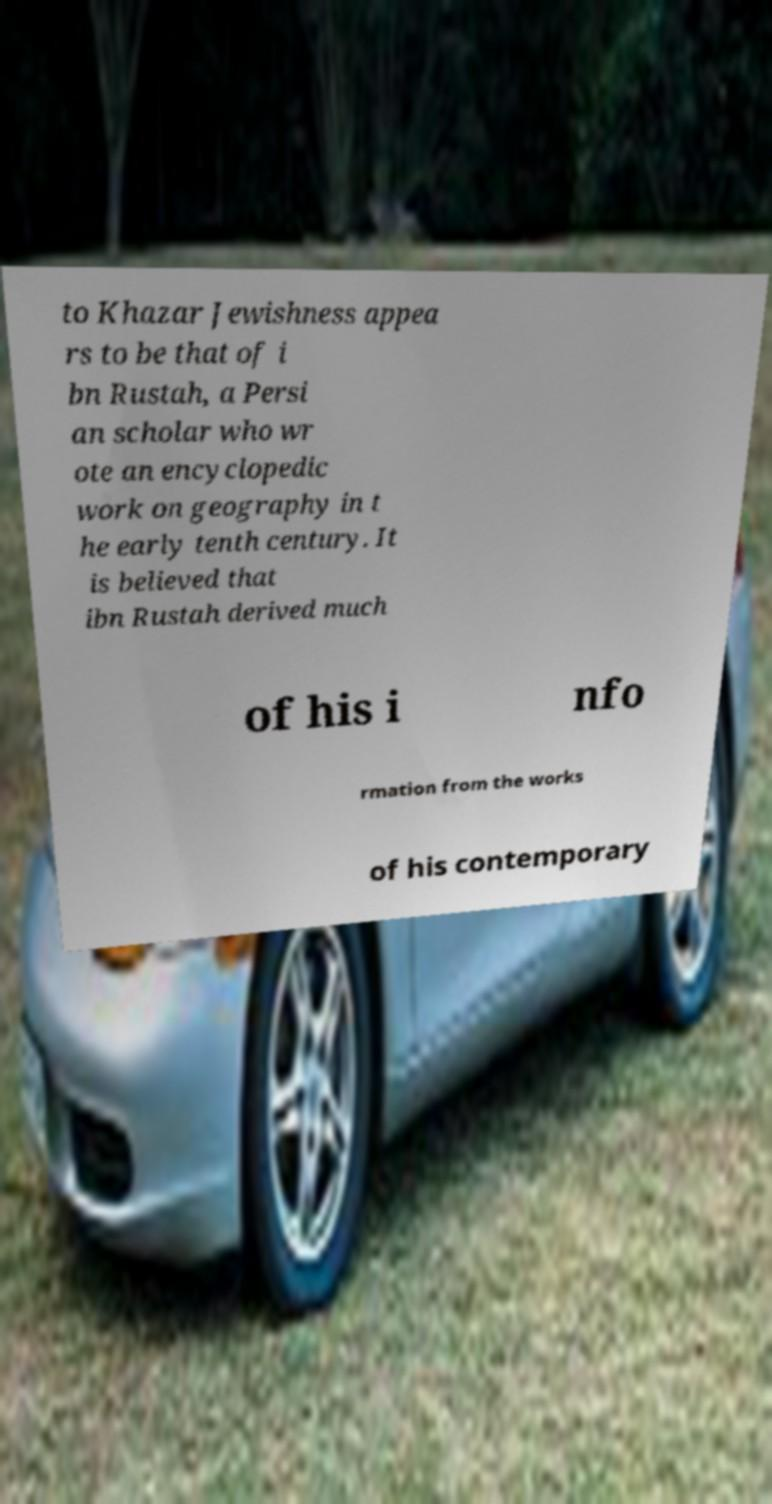Please identify and transcribe the text found in this image. to Khazar Jewishness appea rs to be that of i bn Rustah, a Persi an scholar who wr ote an encyclopedic work on geography in t he early tenth century. It is believed that ibn Rustah derived much of his i nfo rmation from the works of his contemporary 